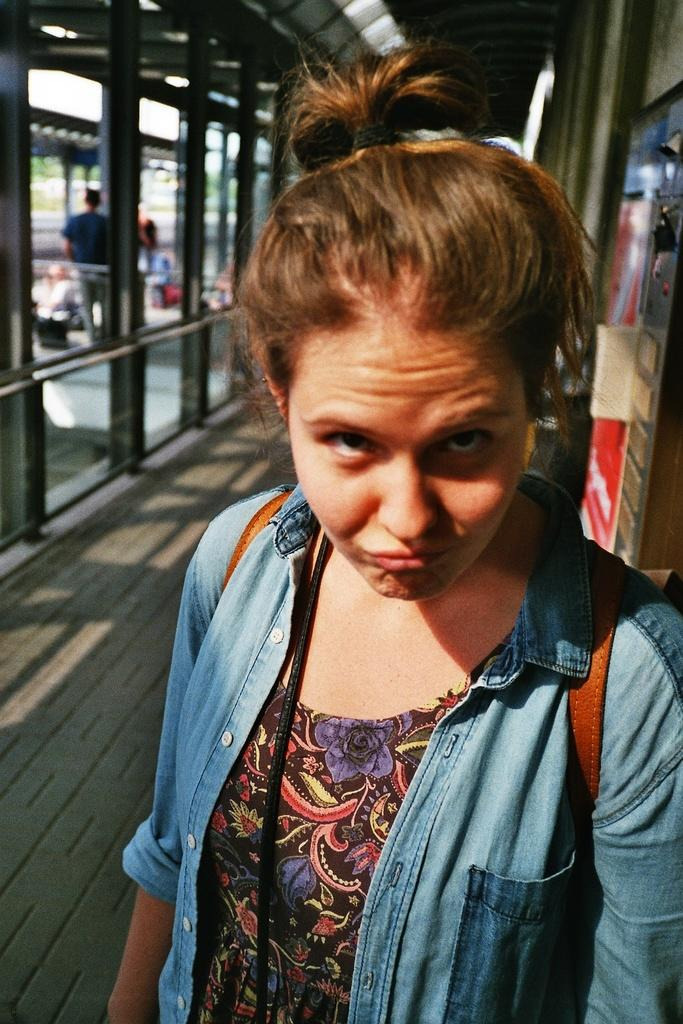Who is the main subject in the foreground of the image? There is a woman in the foreground of the image. What can be seen behind the woman? There are poles visible behind the woman. Are there any other people in the image? Yes, there are other people behind the poles in the image. What type of hobbies does the dirt in the image enjoy? There is no dirt present in the image, so it cannot be determined what hobbies it might enjoy. 